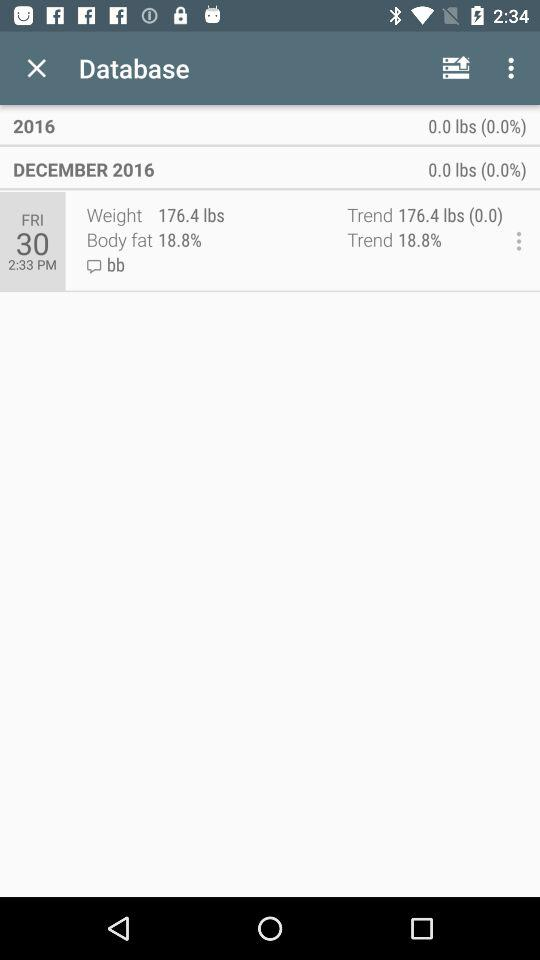What is the percentage of body fat? The percentage of body fat is 18.8. 